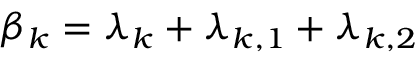Convert formula to latex. <formula><loc_0><loc_0><loc_500><loc_500>\beta _ { k } = \lambda _ { k } + \lambda _ { k , 1 } + \lambda _ { k , 2 }</formula> 